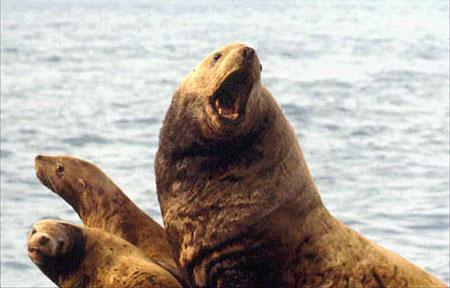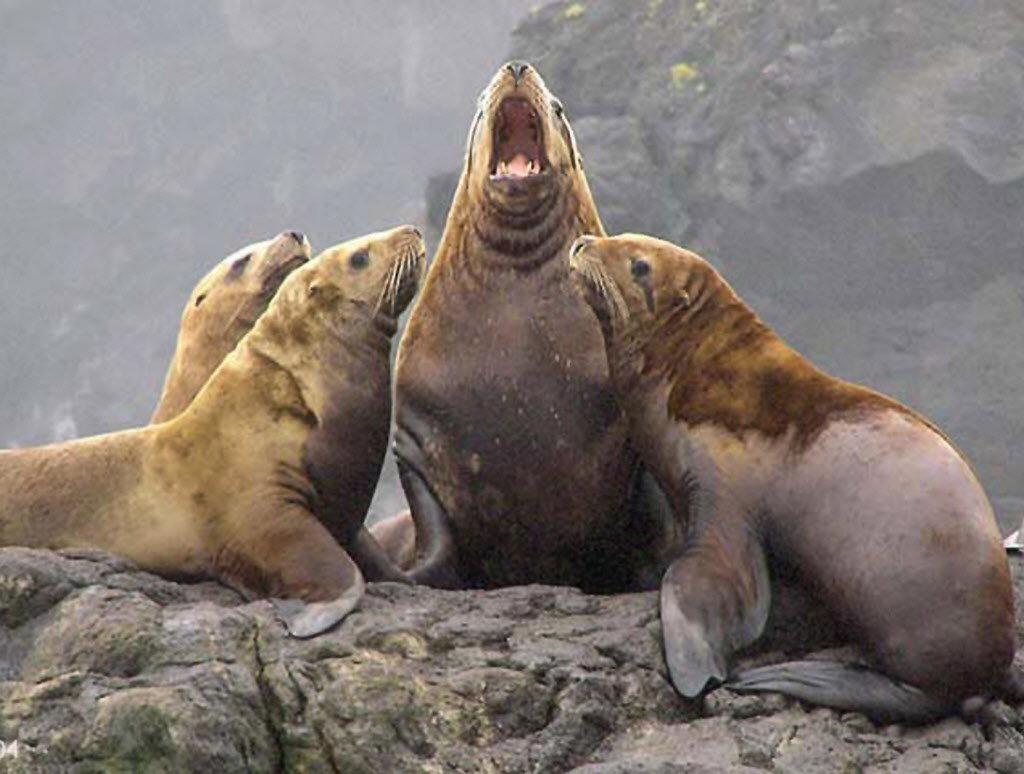The first image is the image on the left, the second image is the image on the right. Given the left and right images, does the statement "In at least one image there is a lone seal sitting in shallow water" hold true? Answer yes or no. No. The first image is the image on the left, the second image is the image on the right. Evaluate the accuracy of this statement regarding the images: "One seal is in the water facing left in one image.". Is it true? Answer yes or no. No. 